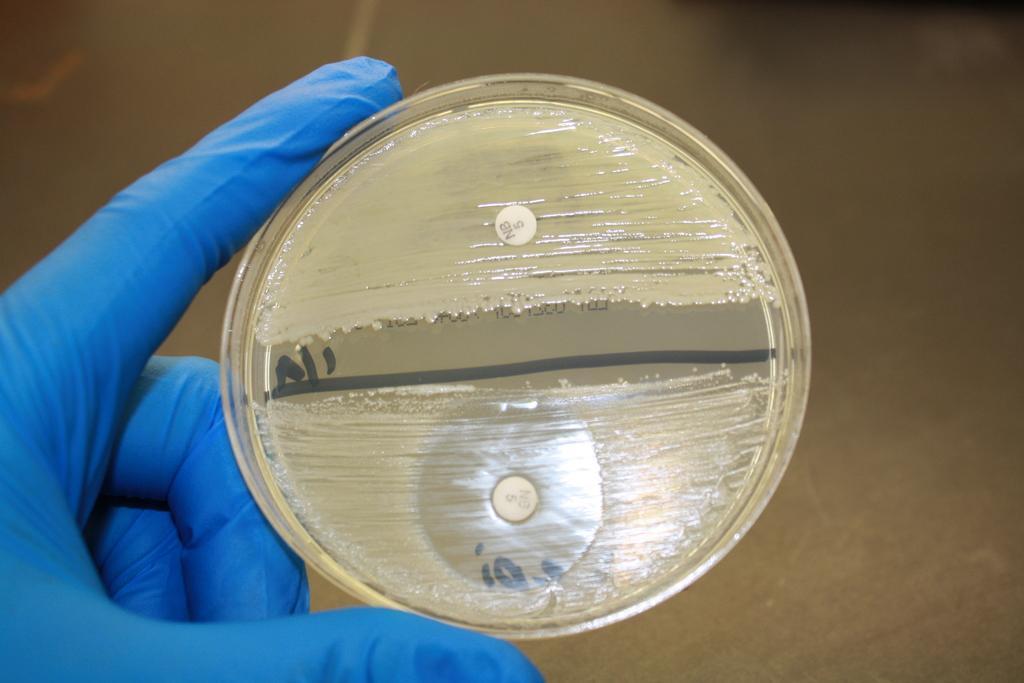Describe this image in one or two sentences. This is a zoomed in picture. On the left we can see the hand of a person wearing blue color glove and holding an object. In the background it seems to be the ground. 